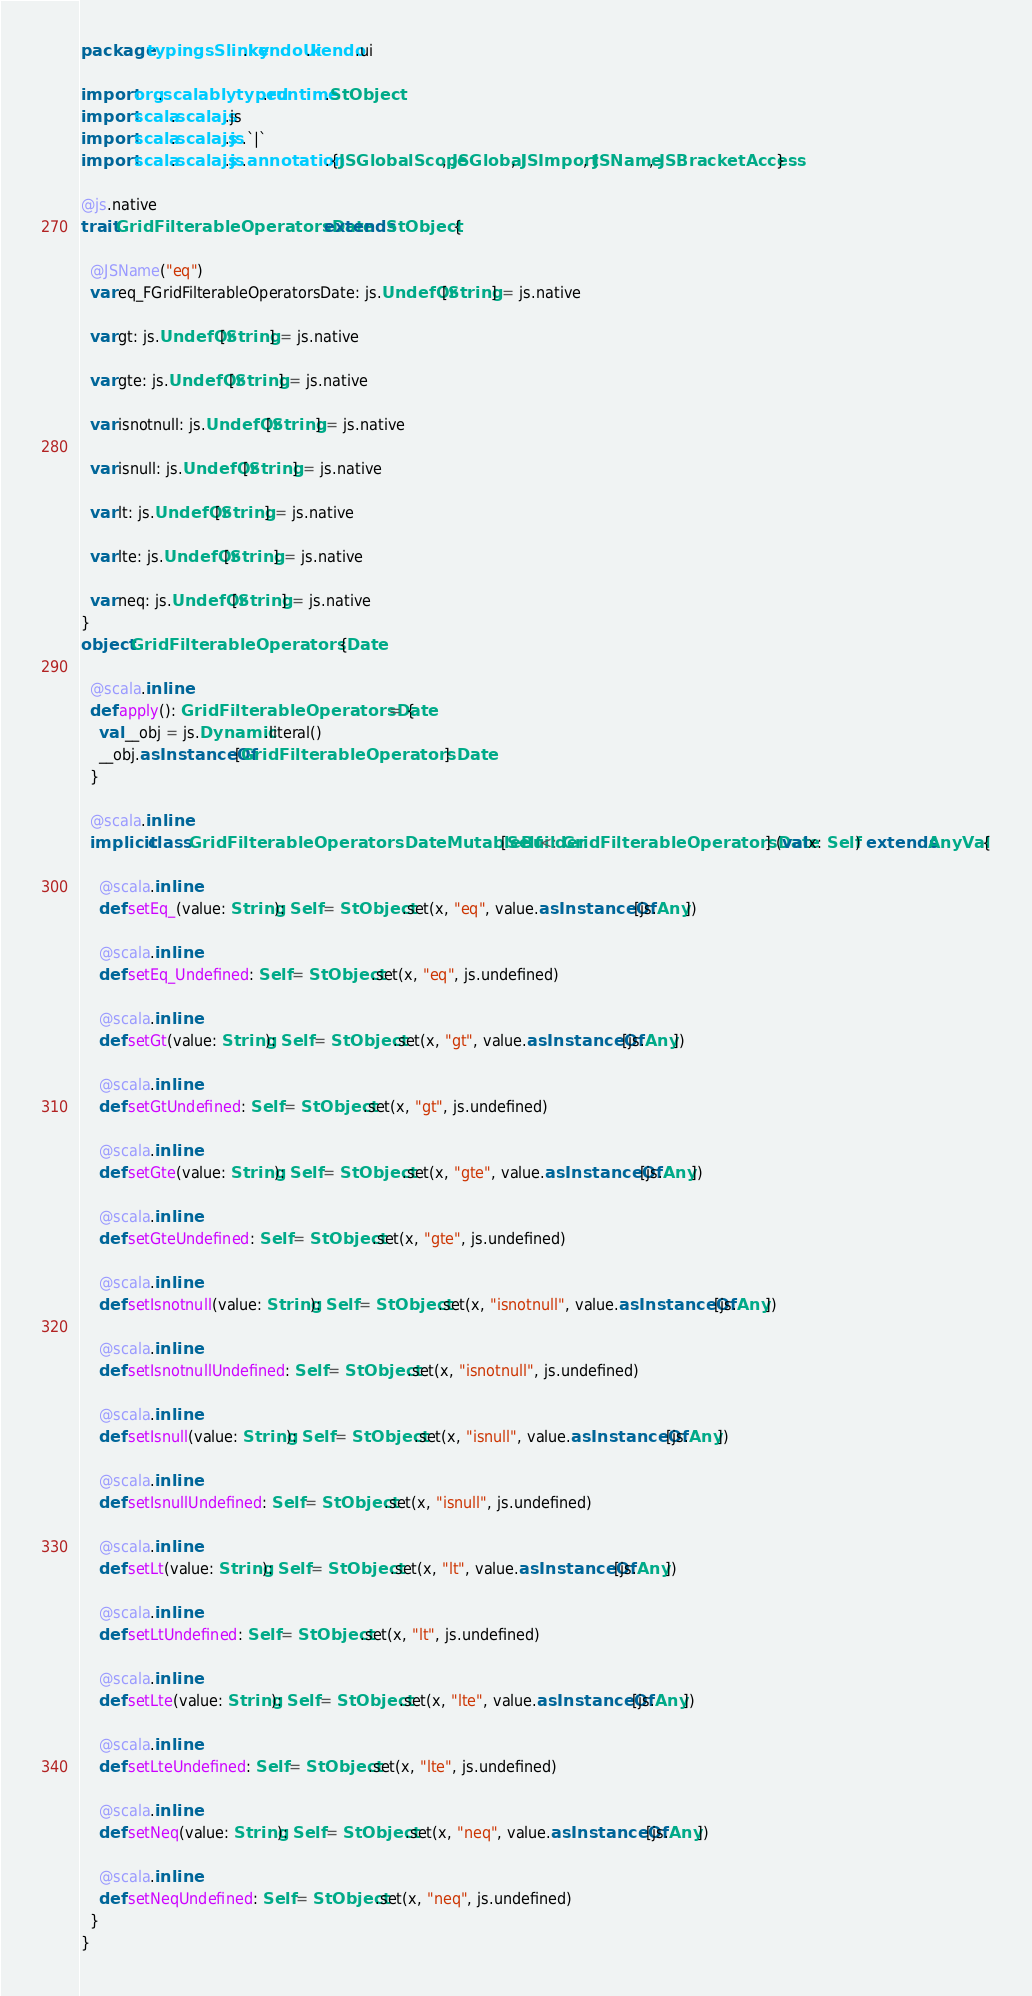<code> <loc_0><loc_0><loc_500><loc_500><_Scala_>package typingsSlinky.kendoUi.kendo.ui

import org.scalablytyped.runtime.StObject
import scala.scalajs.js
import scala.scalajs.js.`|`
import scala.scalajs.js.annotation.{JSGlobalScope, JSGlobal, JSImport, JSName, JSBracketAccess}

@js.native
trait GridFilterableOperatorsDate extends StObject {
  
  @JSName("eq")
  var eq_FGridFilterableOperatorsDate: js.UndefOr[String] = js.native
  
  var gt: js.UndefOr[String] = js.native
  
  var gte: js.UndefOr[String] = js.native
  
  var isnotnull: js.UndefOr[String] = js.native
  
  var isnull: js.UndefOr[String] = js.native
  
  var lt: js.UndefOr[String] = js.native
  
  var lte: js.UndefOr[String] = js.native
  
  var neq: js.UndefOr[String] = js.native
}
object GridFilterableOperatorsDate {
  
  @scala.inline
  def apply(): GridFilterableOperatorsDate = {
    val __obj = js.Dynamic.literal()
    __obj.asInstanceOf[GridFilterableOperatorsDate]
  }
  
  @scala.inline
  implicit class GridFilterableOperatorsDateMutableBuilder[Self <: GridFilterableOperatorsDate] (val x: Self) extends AnyVal {
    
    @scala.inline
    def setEq_(value: String): Self = StObject.set(x, "eq", value.asInstanceOf[js.Any])
    
    @scala.inline
    def setEq_Undefined: Self = StObject.set(x, "eq", js.undefined)
    
    @scala.inline
    def setGt(value: String): Self = StObject.set(x, "gt", value.asInstanceOf[js.Any])
    
    @scala.inline
    def setGtUndefined: Self = StObject.set(x, "gt", js.undefined)
    
    @scala.inline
    def setGte(value: String): Self = StObject.set(x, "gte", value.asInstanceOf[js.Any])
    
    @scala.inline
    def setGteUndefined: Self = StObject.set(x, "gte", js.undefined)
    
    @scala.inline
    def setIsnotnull(value: String): Self = StObject.set(x, "isnotnull", value.asInstanceOf[js.Any])
    
    @scala.inline
    def setIsnotnullUndefined: Self = StObject.set(x, "isnotnull", js.undefined)
    
    @scala.inline
    def setIsnull(value: String): Self = StObject.set(x, "isnull", value.asInstanceOf[js.Any])
    
    @scala.inline
    def setIsnullUndefined: Self = StObject.set(x, "isnull", js.undefined)
    
    @scala.inline
    def setLt(value: String): Self = StObject.set(x, "lt", value.asInstanceOf[js.Any])
    
    @scala.inline
    def setLtUndefined: Self = StObject.set(x, "lt", js.undefined)
    
    @scala.inline
    def setLte(value: String): Self = StObject.set(x, "lte", value.asInstanceOf[js.Any])
    
    @scala.inline
    def setLteUndefined: Self = StObject.set(x, "lte", js.undefined)
    
    @scala.inline
    def setNeq(value: String): Self = StObject.set(x, "neq", value.asInstanceOf[js.Any])
    
    @scala.inline
    def setNeqUndefined: Self = StObject.set(x, "neq", js.undefined)
  }
}
</code> 